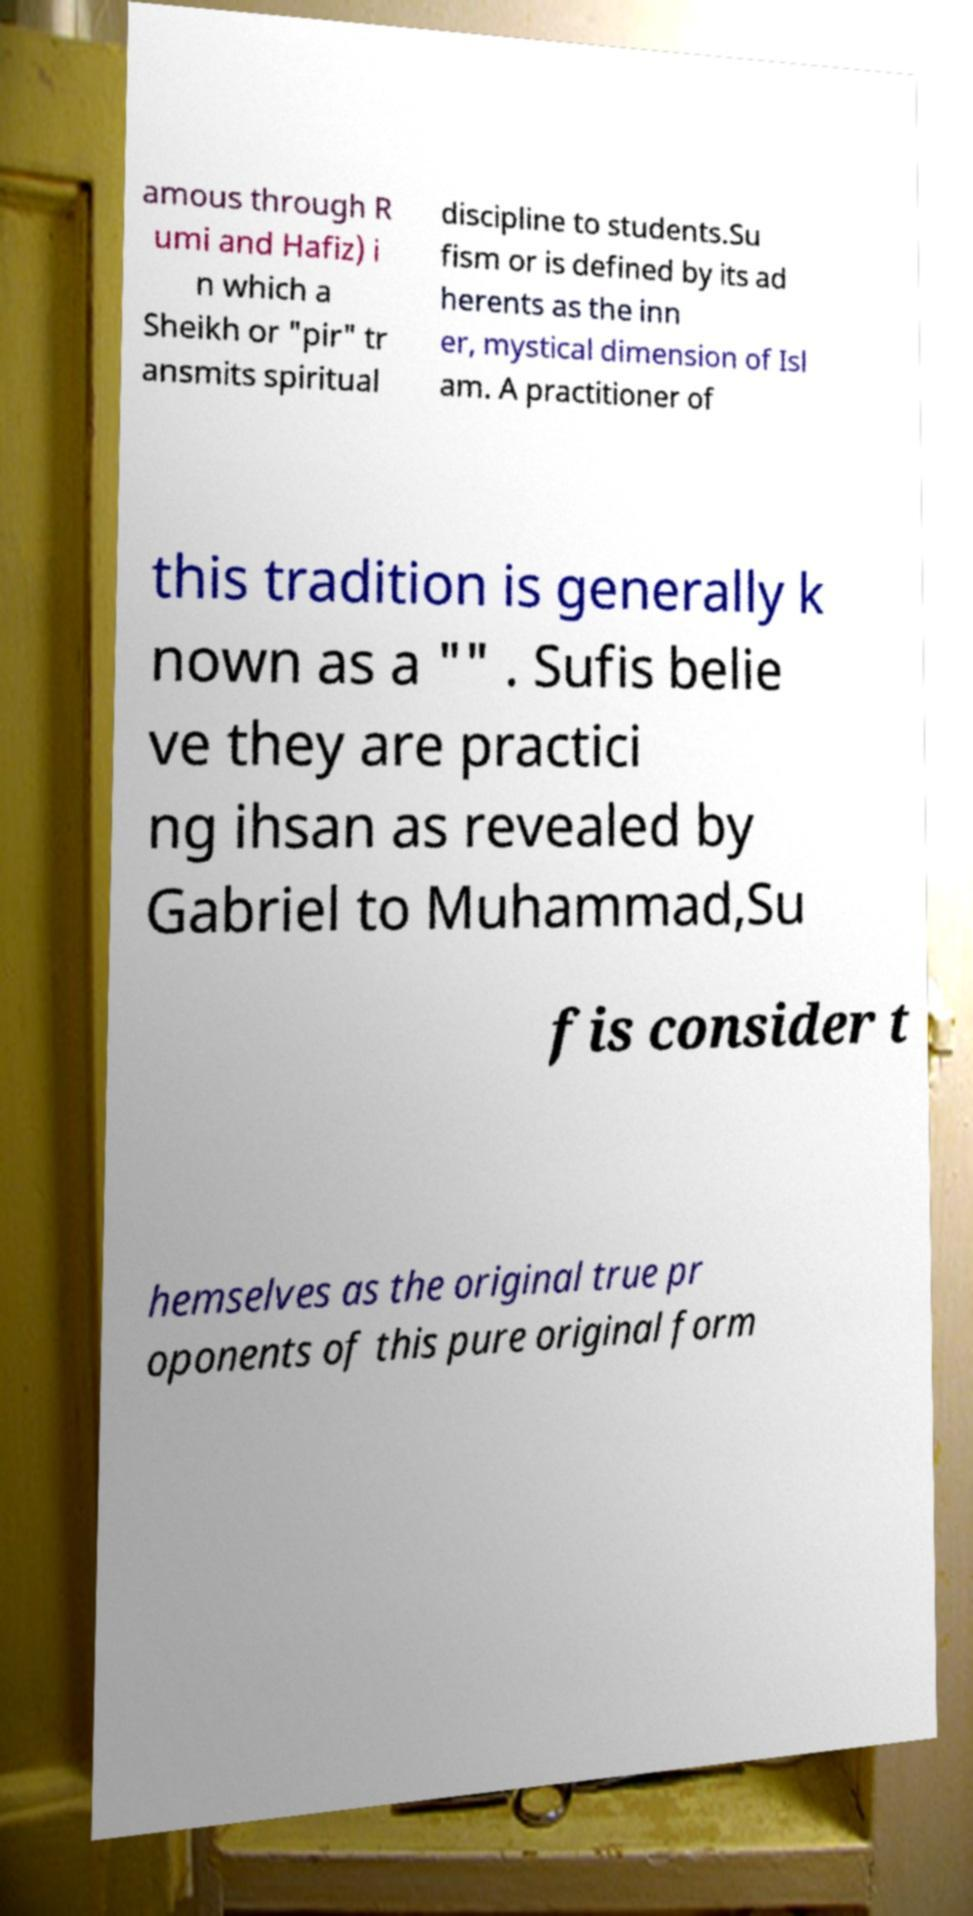Could you extract and type out the text from this image? amous through R umi and Hafiz) i n which a Sheikh or "pir" tr ansmits spiritual discipline to students.Su fism or is defined by its ad herents as the inn er, mystical dimension of Isl am. A practitioner of this tradition is generally k nown as a "" . Sufis belie ve they are practici ng ihsan as revealed by Gabriel to Muhammad,Su fis consider t hemselves as the original true pr oponents of this pure original form 